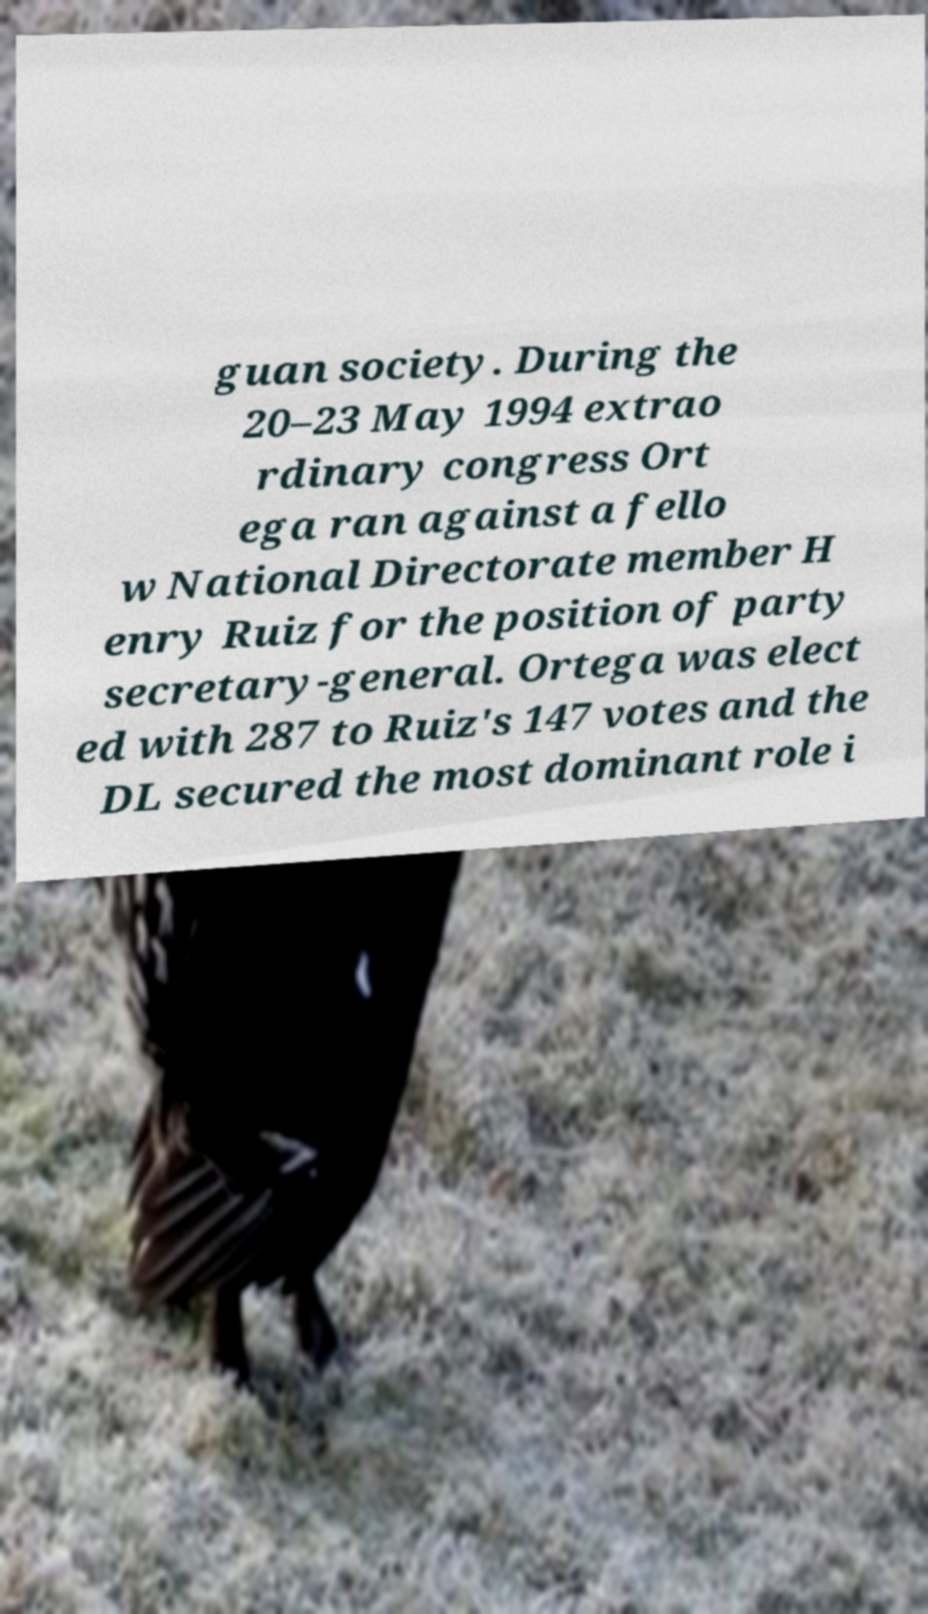I need the written content from this picture converted into text. Can you do that? guan society. During the 20–23 May 1994 extrao rdinary congress Ort ega ran against a fello w National Directorate member H enry Ruiz for the position of party secretary-general. Ortega was elect ed with 287 to Ruiz's 147 votes and the DL secured the most dominant role i 